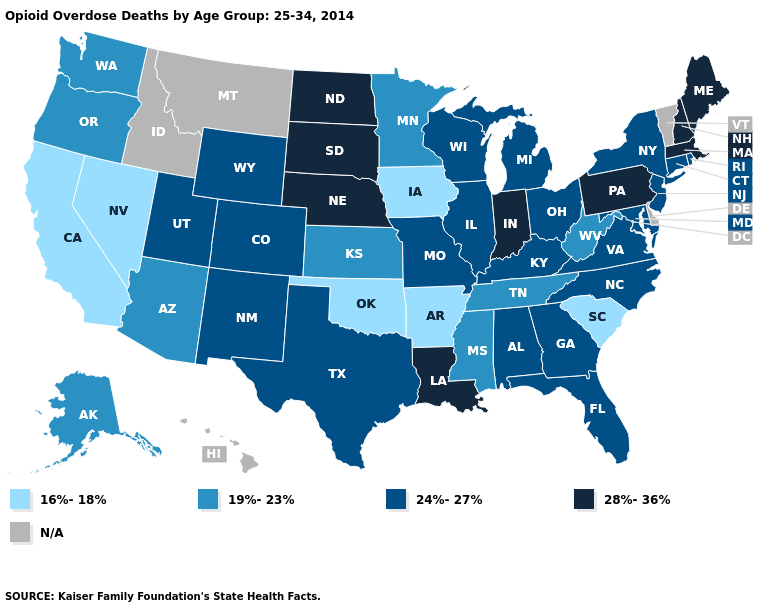What is the value of Virginia?
Write a very short answer. 24%-27%. Which states hav the highest value in the Northeast?
Concise answer only. Maine, Massachusetts, New Hampshire, Pennsylvania. What is the lowest value in the USA?
Give a very brief answer. 16%-18%. Does Arkansas have the highest value in the USA?
Write a very short answer. No. What is the highest value in the USA?
Keep it brief. 28%-36%. Name the states that have a value in the range 24%-27%?
Quick response, please. Alabama, Colorado, Connecticut, Florida, Georgia, Illinois, Kentucky, Maryland, Michigan, Missouri, New Jersey, New Mexico, New York, North Carolina, Ohio, Rhode Island, Texas, Utah, Virginia, Wisconsin, Wyoming. Name the states that have a value in the range 28%-36%?
Write a very short answer. Indiana, Louisiana, Maine, Massachusetts, Nebraska, New Hampshire, North Dakota, Pennsylvania, South Dakota. Name the states that have a value in the range 28%-36%?
Keep it brief. Indiana, Louisiana, Maine, Massachusetts, Nebraska, New Hampshire, North Dakota, Pennsylvania, South Dakota. What is the value of Louisiana?
Answer briefly. 28%-36%. Does the map have missing data?
Short answer required. Yes. What is the value of Connecticut?
Write a very short answer. 24%-27%. Does the map have missing data?
Keep it brief. Yes. What is the value of Florida?
Answer briefly. 24%-27%. 